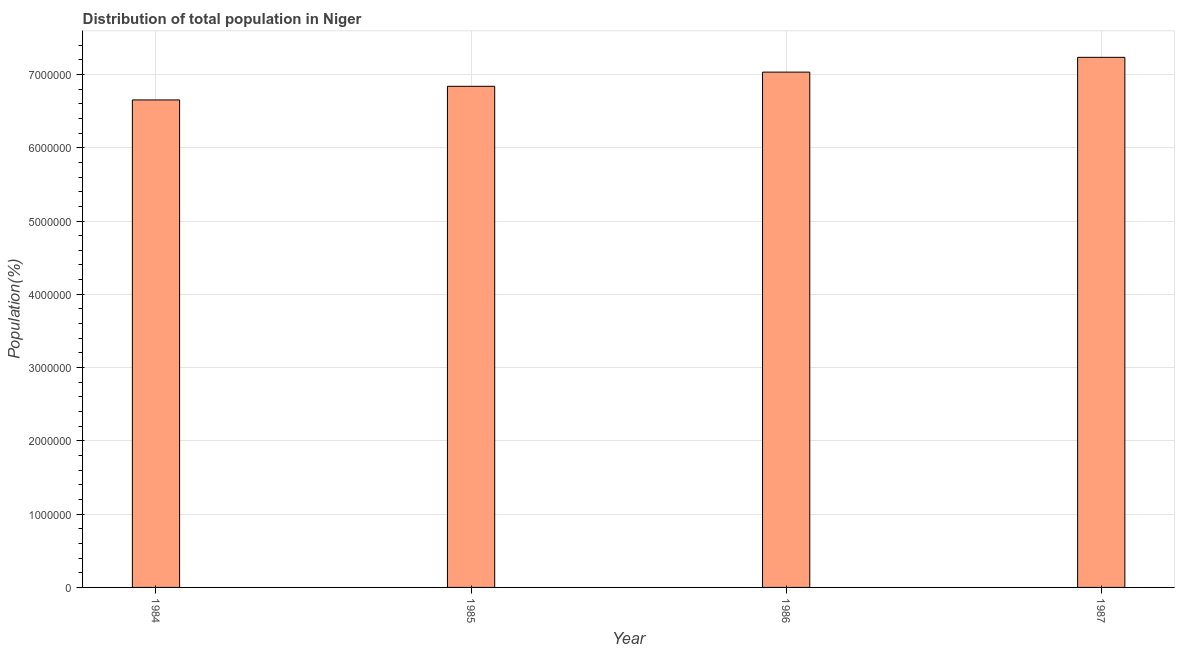Does the graph contain any zero values?
Make the answer very short. No. Does the graph contain grids?
Make the answer very short. Yes. What is the title of the graph?
Your response must be concise. Distribution of total population in Niger . What is the label or title of the X-axis?
Provide a succinct answer. Year. What is the label or title of the Y-axis?
Your response must be concise. Population(%). What is the population in 1987?
Keep it short and to the point. 7.23e+06. Across all years, what is the maximum population?
Your answer should be compact. 7.23e+06. Across all years, what is the minimum population?
Provide a short and direct response. 6.65e+06. What is the sum of the population?
Provide a succinct answer. 2.78e+07. What is the difference between the population in 1985 and 1987?
Provide a succinct answer. -3.95e+05. What is the average population per year?
Your response must be concise. 6.94e+06. What is the median population?
Your response must be concise. 6.93e+06. In how many years, is the population greater than 5600000 %?
Your answer should be compact. 4. What is the ratio of the population in 1984 to that in 1986?
Give a very brief answer. 0.95. Is the difference between the population in 1985 and 1987 greater than the difference between any two years?
Provide a succinct answer. No. What is the difference between the highest and the second highest population?
Your answer should be very brief. 2.02e+05. Is the sum of the population in 1985 and 1987 greater than the maximum population across all years?
Your answer should be very brief. Yes. What is the difference between the highest and the lowest population?
Your answer should be very brief. 5.81e+05. In how many years, is the population greater than the average population taken over all years?
Offer a terse response. 2. Are all the bars in the graph horizontal?
Give a very brief answer. No. How many years are there in the graph?
Make the answer very short. 4. What is the difference between two consecutive major ticks on the Y-axis?
Provide a short and direct response. 1.00e+06. Are the values on the major ticks of Y-axis written in scientific E-notation?
Offer a terse response. No. What is the Population(%) of 1984?
Ensure brevity in your answer.  6.65e+06. What is the Population(%) of 1985?
Your answer should be very brief. 6.84e+06. What is the Population(%) in 1986?
Make the answer very short. 7.03e+06. What is the Population(%) of 1987?
Make the answer very short. 7.23e+06. What is the difference between the Population(%) in 1984 and 1985?
Offer a very short reply. -1.86e+05. What is the difference between the Population(%) in 1984 and 1986?
Give a very brief answer. -3.80e+05. What is the difference between the Population(%) in 1984 and 1987?
Offer a very short reply. -5.81e+05. What is the difference between the Population(%) in 1985 and 1986?
Make the answer very short. -1.94e+05. What is the difference between the Population(%) in 1985 and 1987?
Make the answer very short. -3.95e+05. What is the difference between the Population(%) in 1986 and 1987?
Your answer should be very brief. -2.02e+05. What is the ratio of the Population(%) in 1984 to that in 1985?
Your response must be concise. 0.97. What is the ratio of the Population(%) in 1984 to that in 1986?
Provide a short and direct response. 0.95. What is the ratio of the Population(%) in 1984 to that in 1987?
Your response must be concise. 0.92. What is the ratio of the Population(%) in 1985 to that in 1986?
Your answer should be compact. 0.97. What is the ratio of the Population(%) in 1985 to that in 1987?
Offer a very short reply. 0.94. What is the ratio of the Population(%) in 1986 to that in 1987?
Offer a terse response. 0.97. 